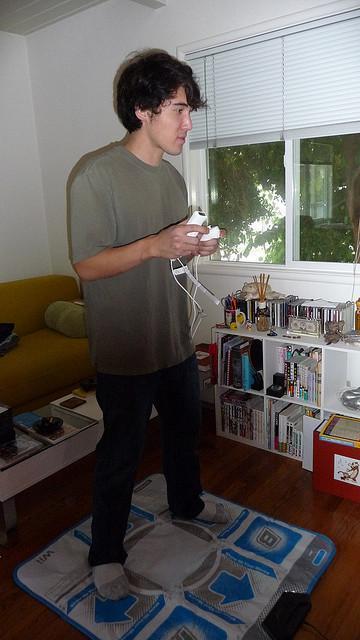Is the statement "The person is in front of the couch." accurate regarding the image?
Answer yes or no. Yes. 